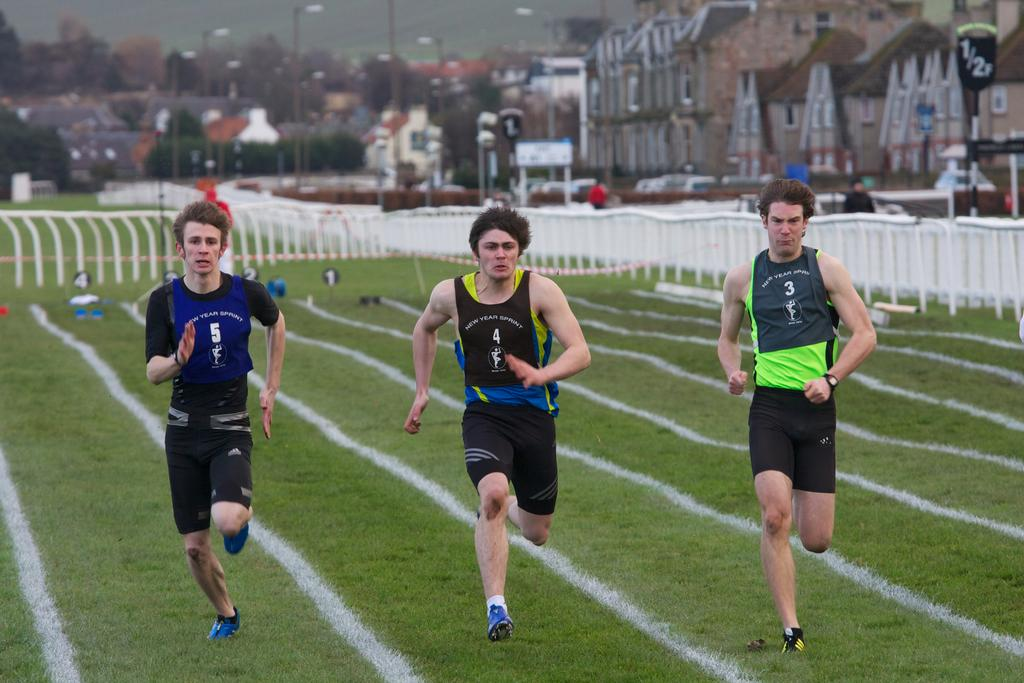<image>
Present a compact description of the photo's key features. three people running with the one in the middle wearing the number 4 